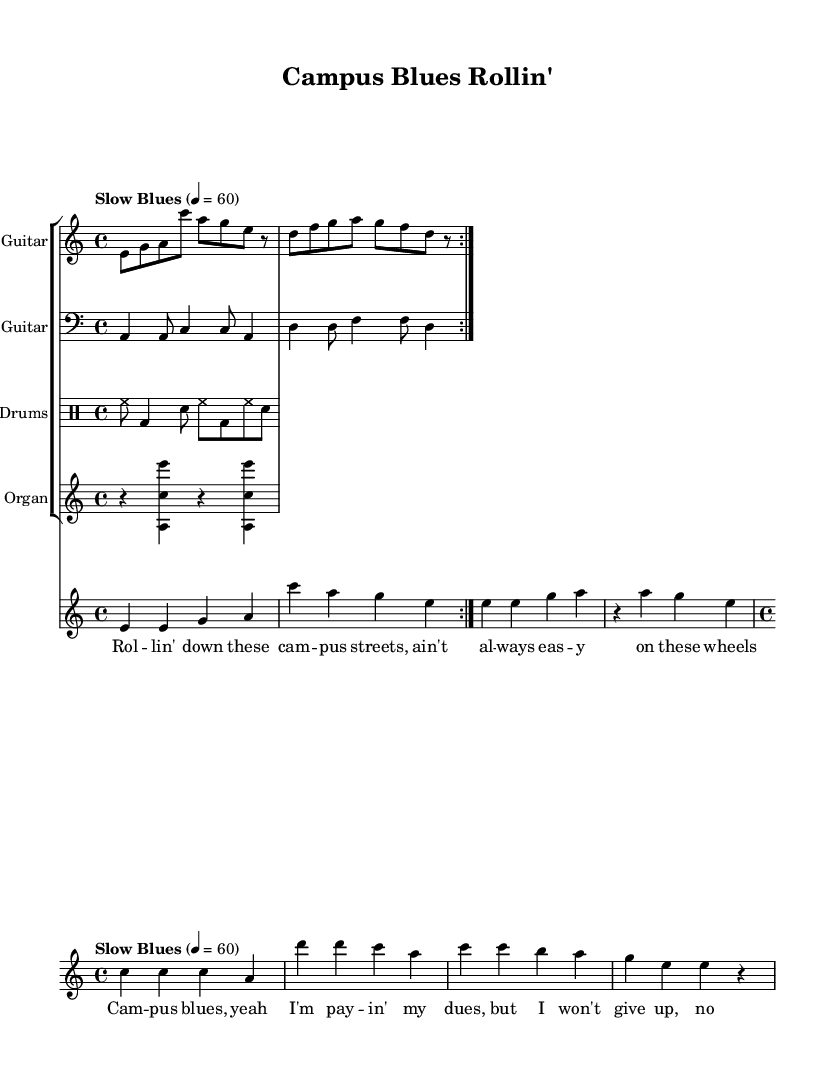What is the key signature of this music? The key signature shown in the music is A minor, which is indicated by the absence of sharps or flats.
Answer: A minor What is the time signature of this music? The time signature is indicated to be 4/4, which means there are four beats in each measure and the quarter note receives one beat.
Answer: 4/4 What is the tempo marking for this piece? The tempo marking reads "Slow Blues," indicating the piece is intended to be played at a slow tempo, specifically at 60 beats per minute.
Answer: Slow Blues How many measures are there in the verse section? Counting the number of measures in the verse part, there are eight measures total, indicated by the rhythm notation provided.
Answer: 8 What instruments are featured in this score? The music score includes Electric Guitar, Bass Guitar, Drums, and Hammond Organ as indicated by the instrument names at the start of each staff.
Answer: Electric Guitar, Bass Guitar, Drums, Hammond Organ What is the lyric content of the chorus? The chorus lyrics indicate themes of struggle and resilience, specifically stating "Campus blues, yeah I'm payin' my dues, but I won't give up, no I refuse."
Answer: Campus blues, yeah I'm payin' my dues, but I won't give up, no I refuse Which section contains a repeat? The electric guitar part specifies a repeat, as indicated by the repeat markings present in the notation.
Answer: Electric Guitar 